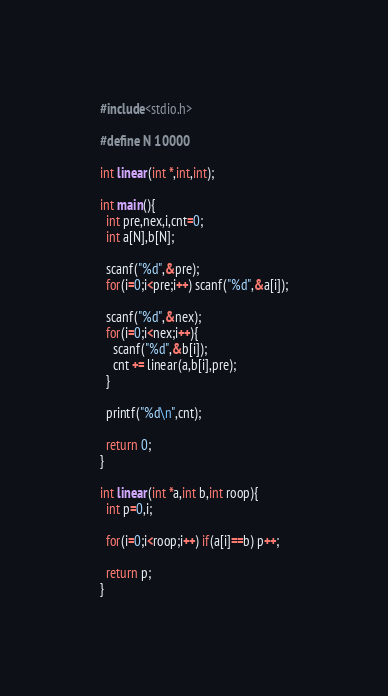<code> <loc_0><loc_0><loc_500><loc_500><_C_>#include<stdio.h>

#define N 10000

int linear(int *,int,int);

int main(){
  int pre,nex,i,cnt=0;
  int a[N],b[N];

  scanf("%d",&pre);
  for(i=0;i<pre;i++) scanf("%d",&a[i]);

  scanf("%d",&nex);
  for(i=0;i<nex;i++){
    scanf("%d",&b[i]);
    cnt += linear(a,b[i],pre);
  }

  printf("%d\n",cnt);

  return 0;
}

int linear(int *a,int b,int roop){
  int p=0,i;

  for(i=0;i<roop;i++) if(a[i]==b) p++;

  return p;
}</code> 